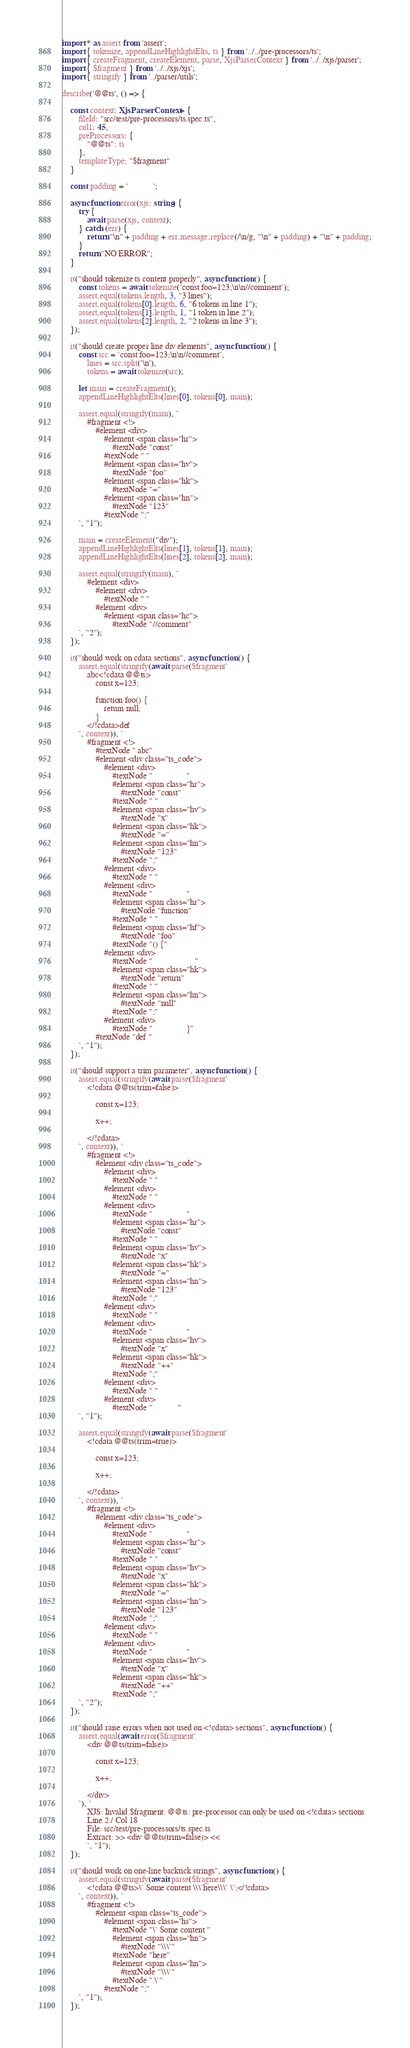<code> <loc_0><loc_0><loc_500><loc_500><_TypeScript_>import * as assert from 'assert';
import { tokenize, appendLineHighlightElts, ts } from '../../pre-processors/ts';
import { createFragment, createElement, parse, XjsParserContext } from '../../xjs/parser';
import { $fragment } from '../../xjs/xjs';
import { stringify } from '../parser/utils';

describe('@@ts', () => {

    const context: XjsParserContext = {
        fileId: "src/test/pre-processors/ts.spec.ts",
        col1: 45,
        preProcessors: {
            "@@ts": ts
        },
        templateType: "$fragment"
    }

    const padding = '            ';

    async function error(xjs: string) {
        try {
            await parse(xjs, context);
        } catch (err) {
            return "\n" + padding + err.message.replace(/\n/g, "\n" + padding) + "\n" + padding;
        }
        return "NO ERROR";
    }

    it("should tokenize ts content properly", async function () {
        const tokens = await tokenize(`const foo=123;\n\n//comment`);
        assert.equal(tokens.length, 3, "3 lines");
        assert.equal(tokens[0].length, 6, "6 tokens in line 1");
        assert.equal(tokens[1].length, 1, "1 token in line 2");
        assert.equal(tokens[2].length, 2, "2 tokens in line 3");
    });

    it("should create proper line div elements", async function () {
        const src = `const foo=123;\n\n//comment`,
            lines = src.split('\n'),
            tokens = await tokenize(src);

        let main = createFragment();
        appendLineHighlightElts(lines[0], tokens[0], main);

        assert.equal(stringify(main), `
            #fragment <!>
                #element <div>
                    #element <span class="hr">
                        #textNode "const"
                    #textNode " "
                    #element <span class="hv">
                        #textNode "foo"
                    #element <span class="hk">
                        #textNode "="
                    #element <span class="hn">
                        #textNode "123"
                    #textNode ";"
        `, "1");

        main = createElement("div");
        appendLineHighlightElts(lines[1], tokens[1], main);
        appendLineHighlightElts(lines[2], tokens[2], main);

        assert.equal(stringify(main), `
            #element <div>
                #element <div>
                    #textNode " "
                #element <div>
                    #element <span class="hc">
                        #textNode "//comment"
        `, "2");
    });

    it("should work on cdata sections", async function () {
        assert.equal(stringify(await parse($fragment`
            abc<!cdata @@ts>
                const x=123;

                function foo() {
                    return null;
                }
            </!cdata>def
        `, context)), `
            #fragment <!>
                #textNode " abc"
                #element <div class="ts_code">
                    #element <div>
                        #textNode "                "
                        #element <span class="hr">
                            #textNode "const"
                        #textNode " "
                        #element <span class="hv">
                            #textNode "x"
                        #element <span class="hk">
                            #textNode "="
                        #element <span class="hn">
                            #textNode "123"
                        #textNode ";"
                    #element <div>
                        #textNode " "
                    #element <div>
                        #textNode "                "
                        #element <span class="hr">
                            #textNode "function"
                        #textNode " "
                        #element <span class="hf">
                            #textNode "foo"
                        #textNode "() {"
                    #element <div>
                        #textNode "                    "
                        #element <span class="hk">
                            #textNode "return"
                        #textNode " "
                        #element <span class="hn">
                            #textNode "null"
                        #textNode ";"
                    #element <div>
                        #textNode "                }"
                #textNode "def "
        `, "1");
    });

    it("should support a trim parameter", async function () {
        assert.equal(stringify(await parse($fragment`
            <!cdata @@ts(trim=false)>

                const x=123;

                x++;

            </!cdata>
        `, context)), `
            #fragment <!>
                #element <div class="ts_code">
                    #element <div>
                        #textNode " "
                    #element <div>
                        #textNode " "
                    #element <div>
                        #textNode "                "
                        #element <span class="hr">
                            #textNode "const"
                        #textNode " "
                        #element <span class="hv">
                            #textNode "x"
                        #element <span class="hk">
                            #textNode "="
                        #element <span class="hn">
                            #textNode "123"
                        #textNode ";"
                    #element <div>
                        #textNode " "
                    #element <div>
                        #textNode "                "
                        #element <span class="hv">
                            #textNode "x"
                        #element <span class="hk">
                            #textNode "++"
                        #textNode ";"
                    #element <div>
                        #textNode " "
                    #element <div>
                        #textNode "            "
        `, "1");

        assert.equal(stringify(await parse($fragment`
            <!cdata @@ts(trim=true)>

                const x=123;

                x++;

            </!cdata>
        `, context)), `
            #fragment <!>
                #element <div class="ts_code">
                    #element <div>
                        #textNode "                "
                        #element <span class="hr">
                            #textNode "const"
                        #textNode " "
                        #element <span class="hv">
                            #textNode "x"
                        #element <span class="hk">
                            #textNode "="
                        #element <span class="hn">
                            #textNode "123"
                        #textNode ";"
                    #element <div>
                        #textNode " "
                    #element <div>
                        #textNode "                "
                        #element <span class="hv">
                            #textNode "x"
                        #element <span class="hk">
                            #textNode "++"
                        #textNode ";"
        `, "2");
    });

    it("should raise errors when not used on <!cdata> sections", async function () {
        assert.equal(await error($fragment`
            <div @@ts(trim=false)>

                const x=123;

                x++;

            </div>
        `), `
            XJS: Invalid $fragment: @@ts: pre-processor can only be used on <!cdata> sections
            Line 2 / Col 18
            File: src/test/pre-processors/ts.spec.ts
            Extract: >> <div @@ts(trim=false)> <<
            `, "1");
    });

    it("should work on one-line backtick strings", async function () {
        assert.equal(stringify(await parse($fragment`
            <!cdata @@ts>\` Some content \\\`here\\\` \`;</!cdata>
        `, context)), `
            #fragment <!>
                #element <span class="ts_code">
                    #element <span class="hs">
                        #textNode "\` Some content "
                        #element <span class="hn">
                            #textNode "\\\`"
                        #textNode "here"
                        #element <span class="hn">
                            #textNode "\\\`"
                        #textNode " \`"
                    #textNode ";"
        `, "1");
    });
</code> 